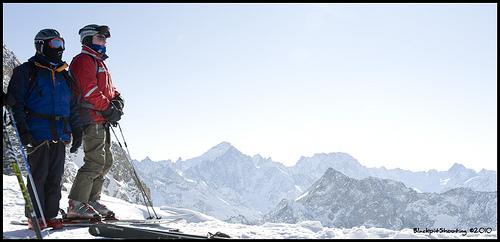What activity are they participating in?
Quick response, please. Skiing. How many people are wearing their goggles?
Short answer required. 1. What color are the people's jackets?
Give a very brief answer. Red and blue. Are they wearing the same outfits?
Short answer required. No. Is there fog in this picture?
Answer briefly. No. How many people are wearing hats?
Give a very brief answer. 2. Is it a cloudy day out?
Be succinct. No. What are these two people doing?
Keep it brief. Skiing. What color are the jackets?
Be succinct. Red and blue. 